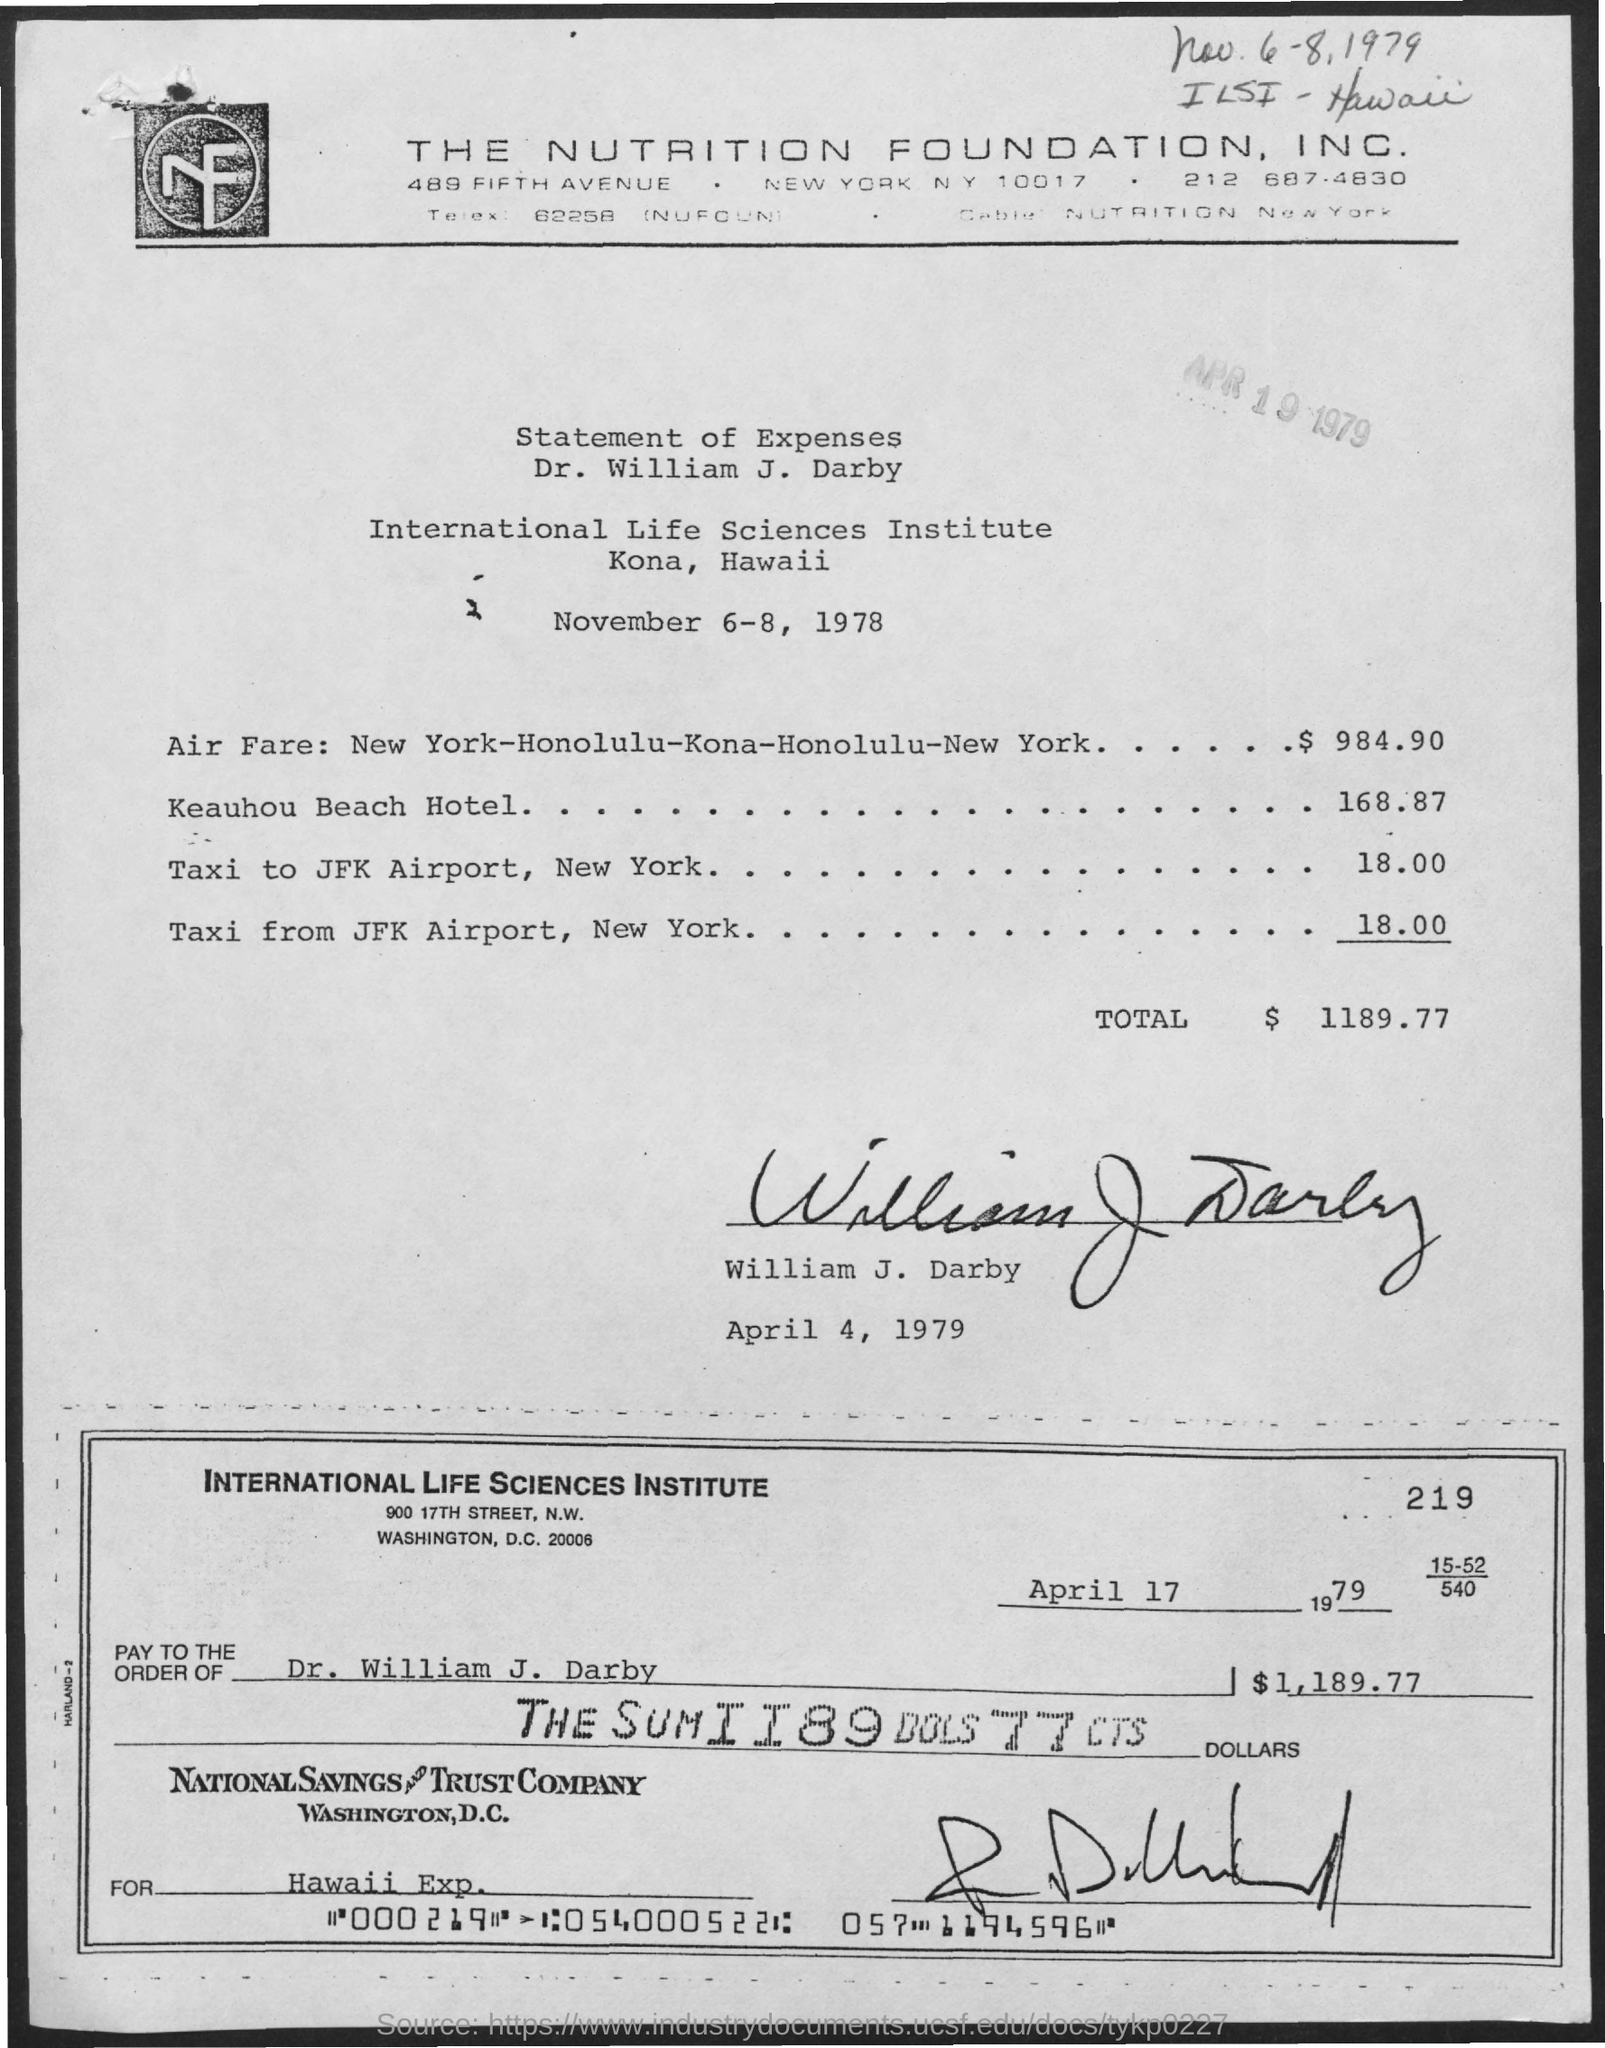Mention a couple of crucial points in this snapshot. The total expenses mentioned in the given page are $1189.77. The check was written to "Dr. William J. Darby" with "whose name was written at pay to the order of as mentioned in the given check. The total cost of airfare for a round-trip journey from New York to Honolulu, followed by a stop in Kona, and then returning to New York is $984.90. The International Life Sciences Institute is the name of the institute. The date mentioned in the given check is April 17, 1979. 